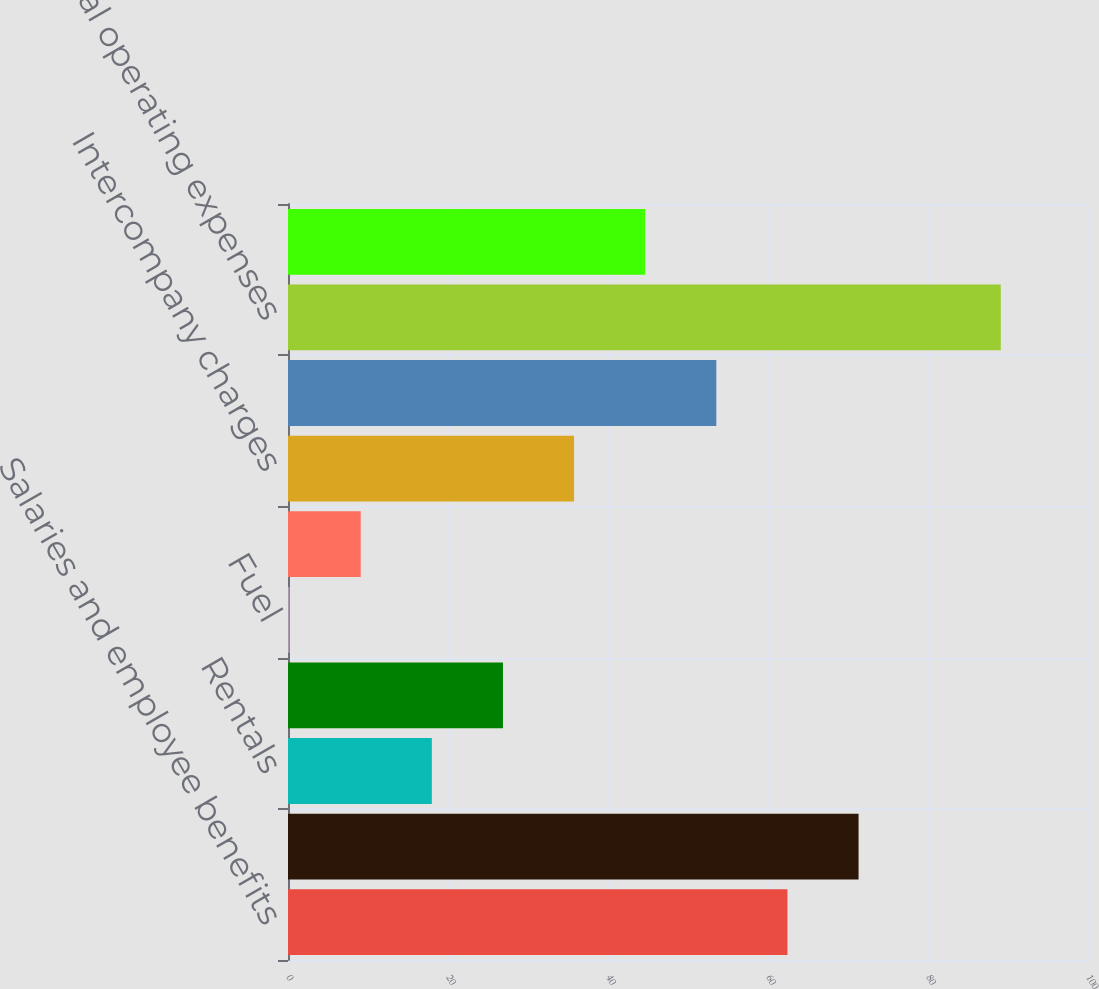Convert chart. <chart><loc_0><loc_0><loc_500><loc_500><bar_chart><fcel>Salaries and employee benefits<fcel>Purchased transportation<fcel>Rentals<fcel>Depreciation and amortization<fcel>Fuel<fcel>Maintenance and repairs<fcel>Intercompany charges<fcel>Other<fcel>Total operating expenses<fcel>Operating margin<nl><fcel>62.43<fcel>71.32<fcel>17.98<fcel>26.87<fcel>0.2<fcel>9.09<fcel>35.76<fcel>53.54<fcel>89.1<fcel>44.65<nl></chart> 